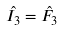Convert formula to latex. <formula><loc_0><loc_0><loc_500><loc_500>\hat { I _ { 3 } } = \hat { F _ { 3 } }</formula> 